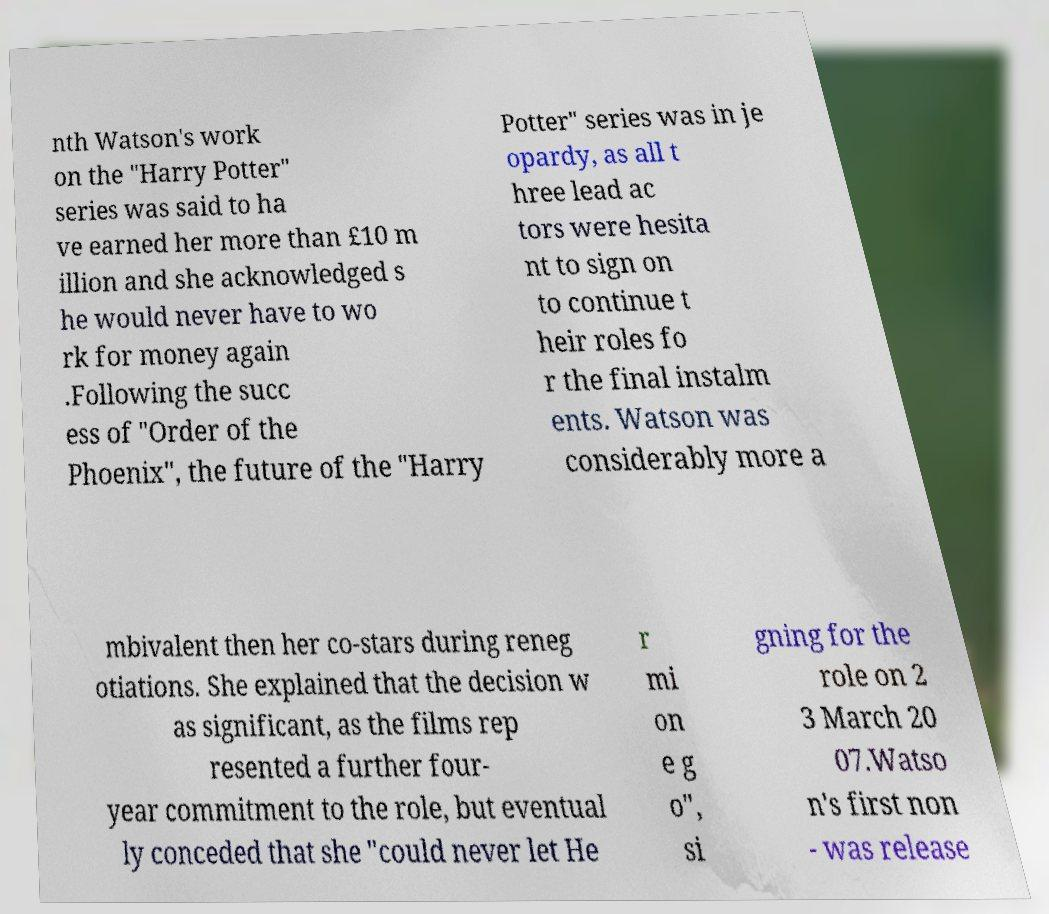Could you extract and type out the text from this image? nth Watson's work on the "Harry Potter" series was said to ha ve earned her more than £10 m illion and she acknowledged s he would never have to wo rk for money again .Following the succ ess of "Order of the Phoenix", the future of the "Harry Potter" series was in je opardy, as all t hree lead ac tors were hesita nt to sign on to continue t heir roles fo r the final instalm ents. Watson was considerably more a mbivalent then her co-stars during reneg otiations. She explained that the decision w as significant, as the films rep resented a further four- year commitment to the role, but eventual ly conceded that she "could never let He r mi on e g o", si gning for the role on 2 3 March 20 07.Watso n's first non - was release 